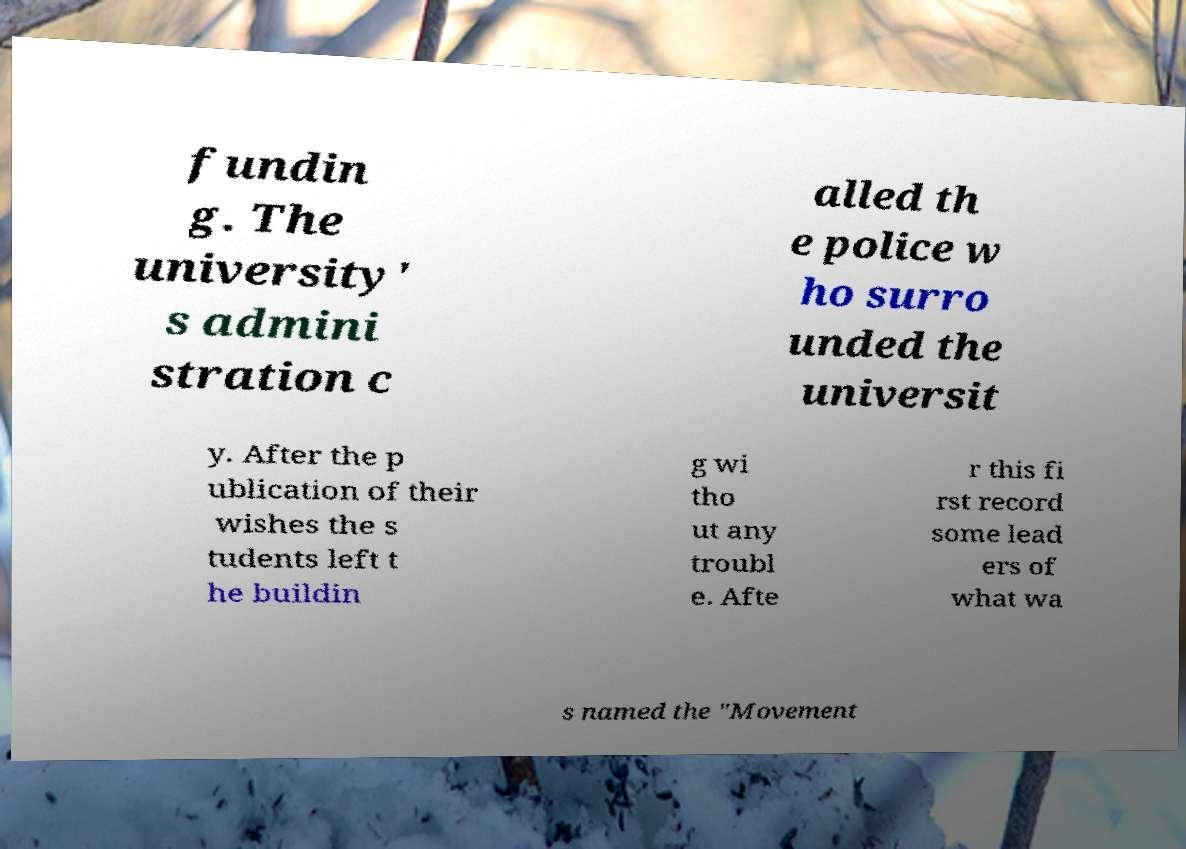Could you assist in decoding the text presented in this image and type it out clearly? fundin g. The university' s admini stration c alled th e police w ho surro unded the universit y. After the p ublication of their wishes the s tudents left t he buildin g wi tho ut any troubl e. Afte r this fi rst record some lead ers of what wa s named the "Movement 